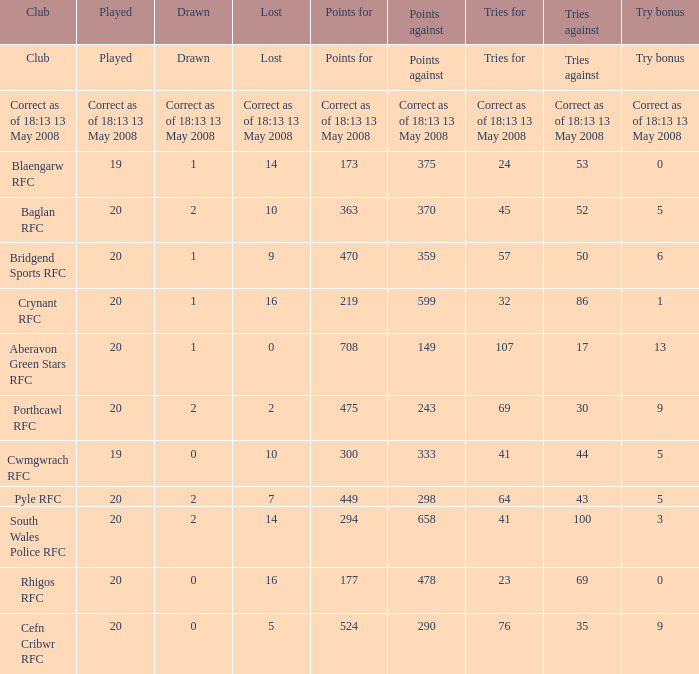What club has a played number of 19, and the lost of 14? Blaengarw RFC. Could you parse the entire table as a dict? {'header': ['Club', 'Played', 'Drawn', 'Lost', 'Points for', 'Points against', 'Tries for', 'Tries against', 'Try bonus'], 'rows': [['Club', 'Played', 'Drawn', 'Lost', 'Points for', 'Points against', 'Tries for', 'Tries against', 'Try bonus'], ['Correct as of 18:13 13 May 2008', 'Correct as of 18:13 13 May 2008', 'Correct as of 18:13 13 May 2008', 'Correct as of 18:13 13 May 2008', 'Correct as of 18:13 13 May 2008', 'Correct as of 18:13 13 May 2008', 'Correct as of 18:13 13 May 2008', 'Correct as of 18:13 13 May 2008', 'Correct as of 18:13 13 May 2008'], ['Blaengarw RFC', '19', '1', '14', '173', '375', '24', '53', '0'], ['Baglan RFC', '20', '2', '10', '363', '370', '45', '52', '5'], ['Bridgend Sports RFC', '20', '1', '9', '470', '359', '57', '50', '6'], ['Crynant RFC', '20', '1', '16', '219', '599', '32', '86', '1'], ['Aberavon Green Stars RFC', '20', '1', '0', '708', '149', '107', '17', '13'], ['Porthcawl RFC', '20', '2', '2', '475', '243', '69', '30', '9'], ['Cwmgwrach RFC', '19', '0', '10', '300', '333', '41', '44', '5'], ['Pyle RFC', '20', '2', '7', '449', '298', '64', '43', '5'], ['South Wales Police RFC', '20', '2', '14', '294', '658', '41', '100', '3'], ['Rhigos RFC', '20', '0', '16', '177', '478', '23', '69', '0'], ['Cefn Cribwr RFC', '20', '0', '5', '524', '290', '76', '35', '9']]} 